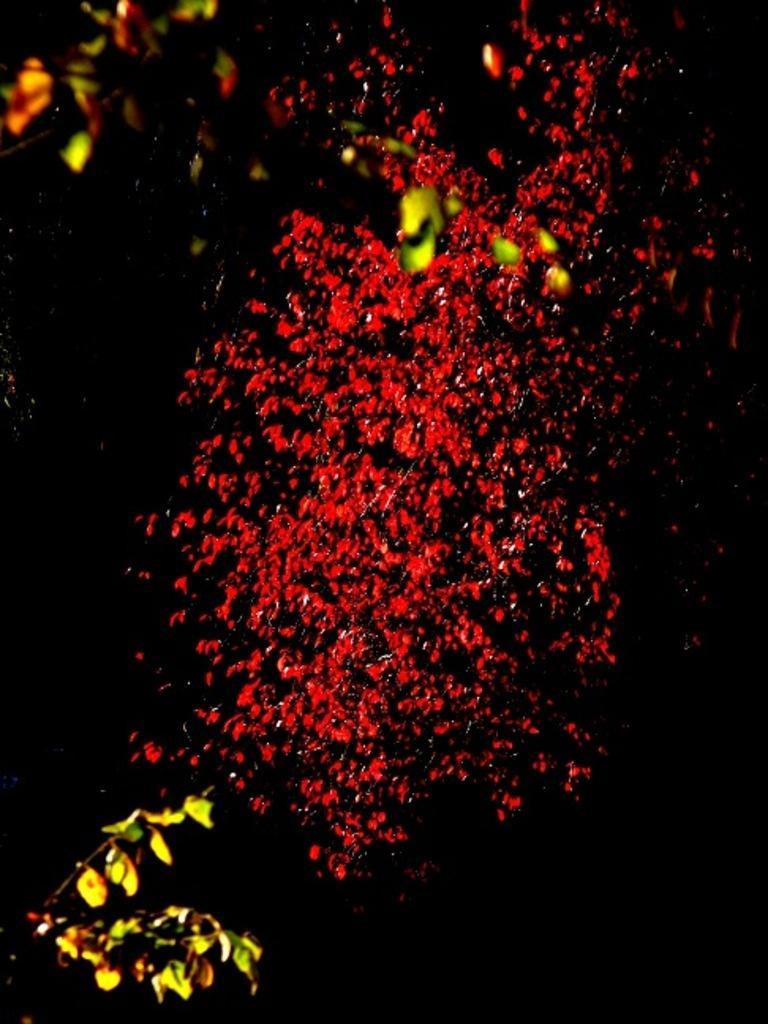Can you describe this image briefly? In this image there are tree branches, maybe there are some red flowers visible in the middle, background is dark. 